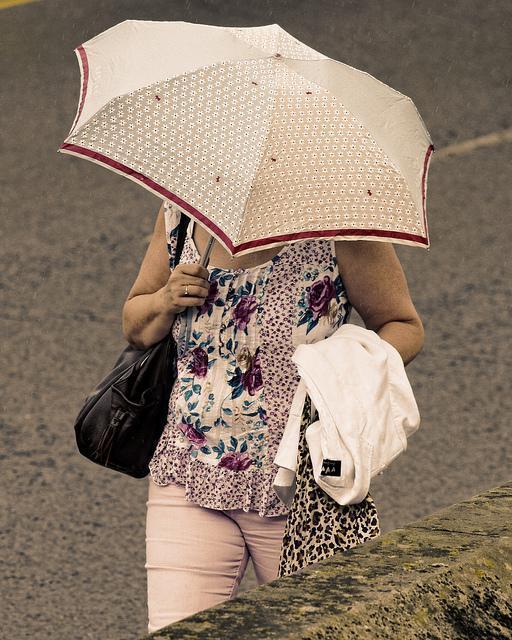Why is she holding an umbrella in dry weather?
Answer the question by selecting the correct answer among the 4 following choices and explain your choice with a short sentence. The answer should be formatted with the following format: `Answer: choice
Rationale: rationale.`
Options: Sun protection, is hiding, confused, likes umbrellas. Answer: sun protection.
Rationale: She wants to keep the sun out. 